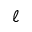Convert formula to latex. <formula><loc_0><loc_0><loc_500><loc_500>\ell</formula> 